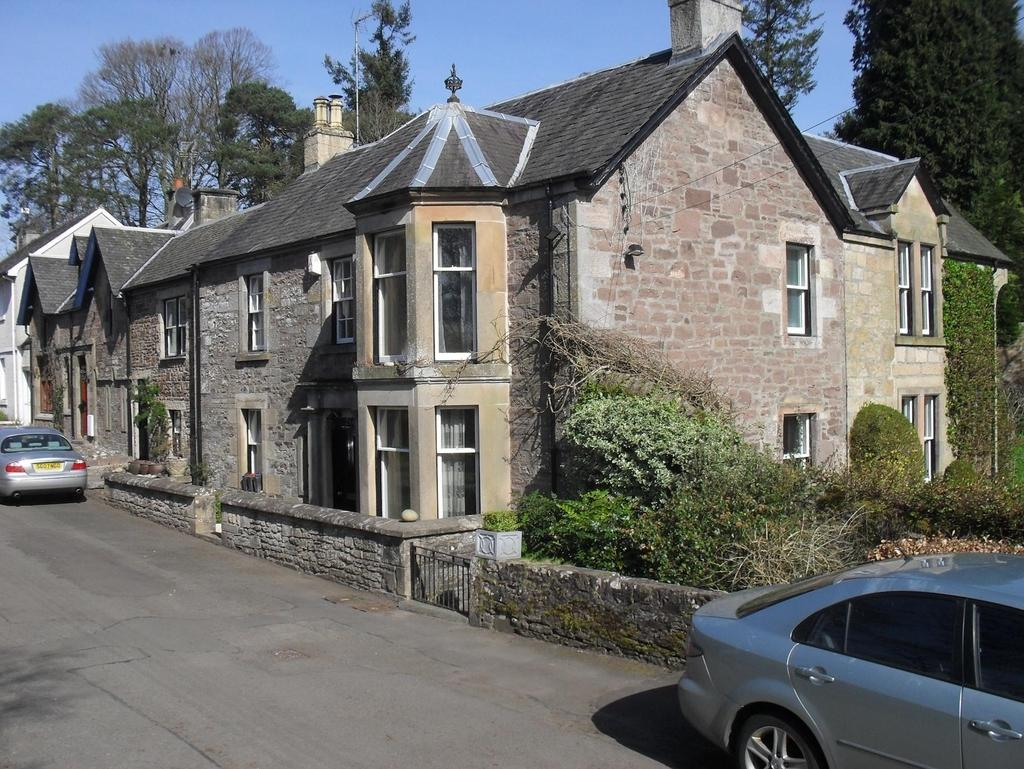How many vehicles are visible on the road in the image? There are two vehicles on the road in the image. What can be seen in the background of the image? In the background, there are trees, which are described as green, and buildings, which are described as gray and cream. What color is the sky in the image? The sky is blue in color. Can you see a pig rubbing against the trees in the image? No, there is no pig present in the image, and the trees are not being rubbed against by any animal. 